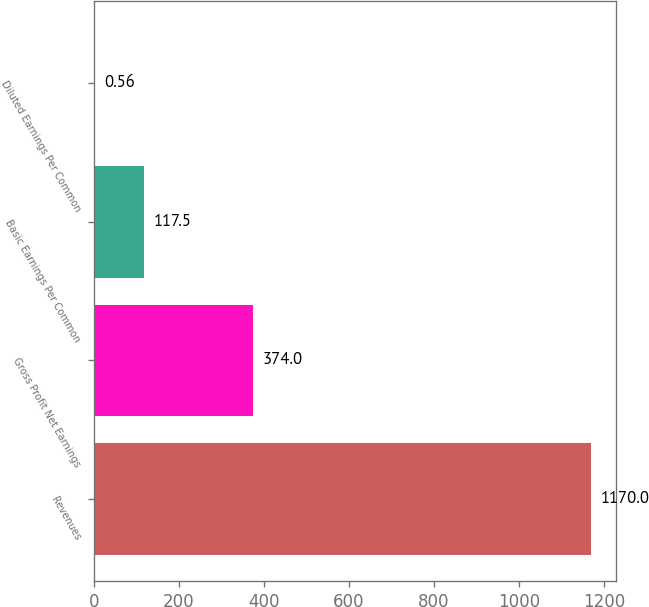Convert chart. <chart><loc_0><loc_0><loc_500><loc_500><bar_chart><fcel>Revenues<fcel>Gross Profit Net Earnings<fcel>Basic Earnings Per Common<fcel>Diluted Earnings Per Common<nl><fcel>1170<fcel>374<fcel>117.5<fcel>0.56<nl></chart> 